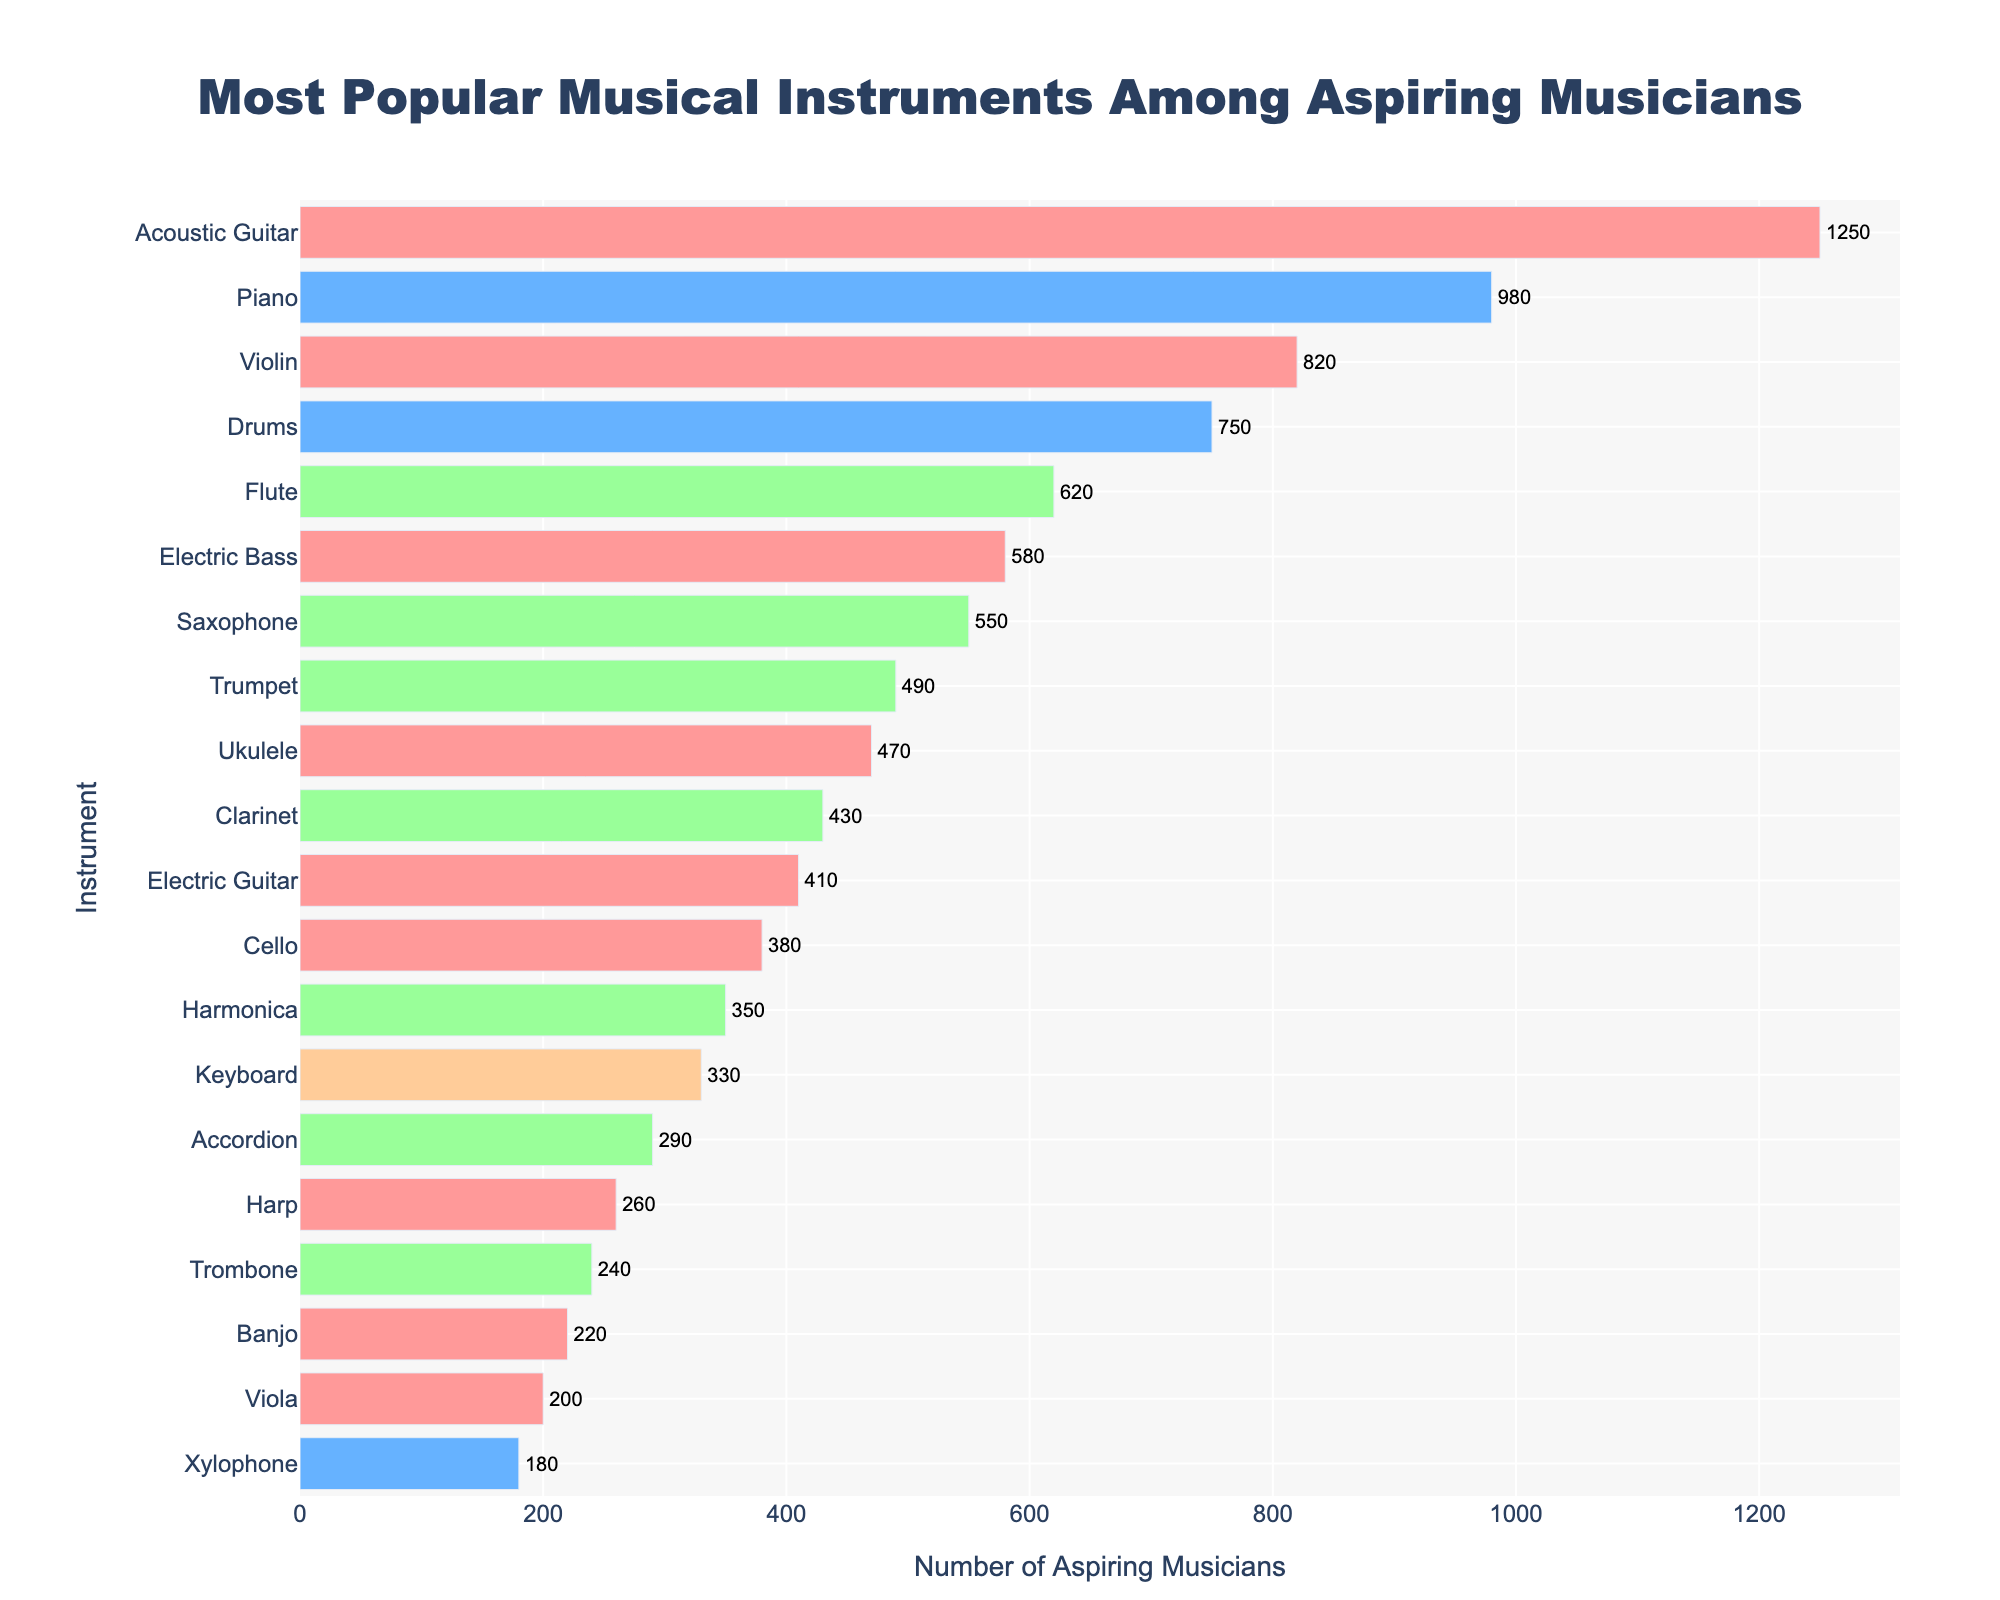What's the most popular instrument among aspiring musicians? To find the most popular instrument, we look for the bar with the highest value on the x-axis. The acoustic guitar has the tallest bar, indicating it is the most popular.
Answer: Acoustic Guitar Which instrument type has the most aspiring musicians overall? To determine this, sum the number of aspiring musicians for each instrument type. For string instruments, sum the numbers associated with all string instruments, and repeat for other types. String instruments have the highest total.
Answer: String How many more aspiring musicians prefer the piano over the drums? Find the number of aspiring musicians for both piano and drums and subtract the smaller value from the larger one. For piano (980) and drums (750), the difference is 980 - 750.
Answer: 230 Which is more popular, the flute or the saxophone, and by how many aspiring musicians? Compare the values for flute (620) and saxophone (550). The flute has a higher value. Subtract the number of saxophone players from the number of flute players to find the difference.
Answer: Flute, by 70 What is the combined number of aspiring musicians for the electric guitar and electric bass? Add the number of aspiring musicians for both instruments. Electric guitar has 410 and electric bass has 580, so the total is 410 + 580.
Answer: 990 Which instrument type is the least represented among aspiring musicians? Sum the number of aspiring musicians for each instrument type. The smallest sum corresponds to electronic instruments.
Answer: Electronic Among the wind instruments, which one is the least popular? Look at all the wind instruments and find the one with the smallest number of aspiring musicians. The trombone (240) has the lowest value among wind instruments.
Answer: Trombone What is the average number of aspiring musicians across all listed instruments? Add the number of aspiring musicians for all instruments and divide by the total number of instruments (20). Sum of all aspiring musicians is 12,800 and 12,800 / 20 = 640.
Answer: 640 Arrange the percussion instruments in descending order by their popularity. Identify all percussion instruments and then list their number of aspiring musicians in descending order: Piano (980), Drums (750), Xylophone (180).
Answer: Piano, Drums, Xylophone Which instrument has just slightly fewer aspiring musicians than the flute? Identify the instrument with 620 aspiring musicians (Flute), then find the next highest bar with a slightly lower value. The saxophone (550) is just below.
Answer: Saxophone 